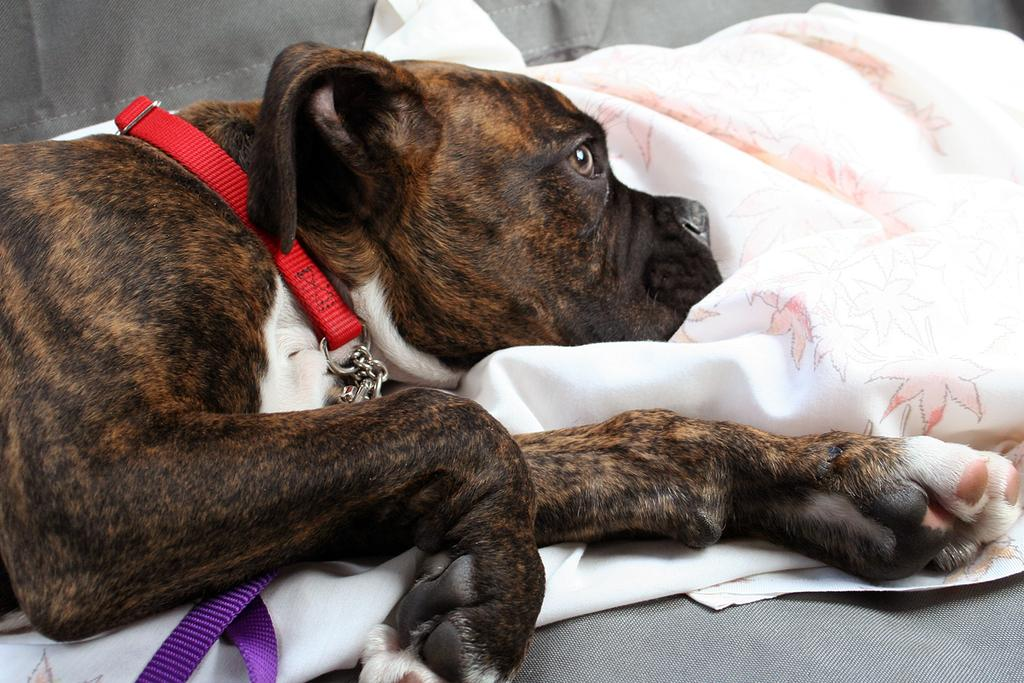What is the main subject in the center of the image? There is a dog in the center of the image. What object is located beside the dog? There is a blanket beside the dog. What type of furniture is at the bottom of the image? There is a couch at the bottom of the image. What type of noise is the dog making in the image? The image does not provide any information about the dog making a noise. 